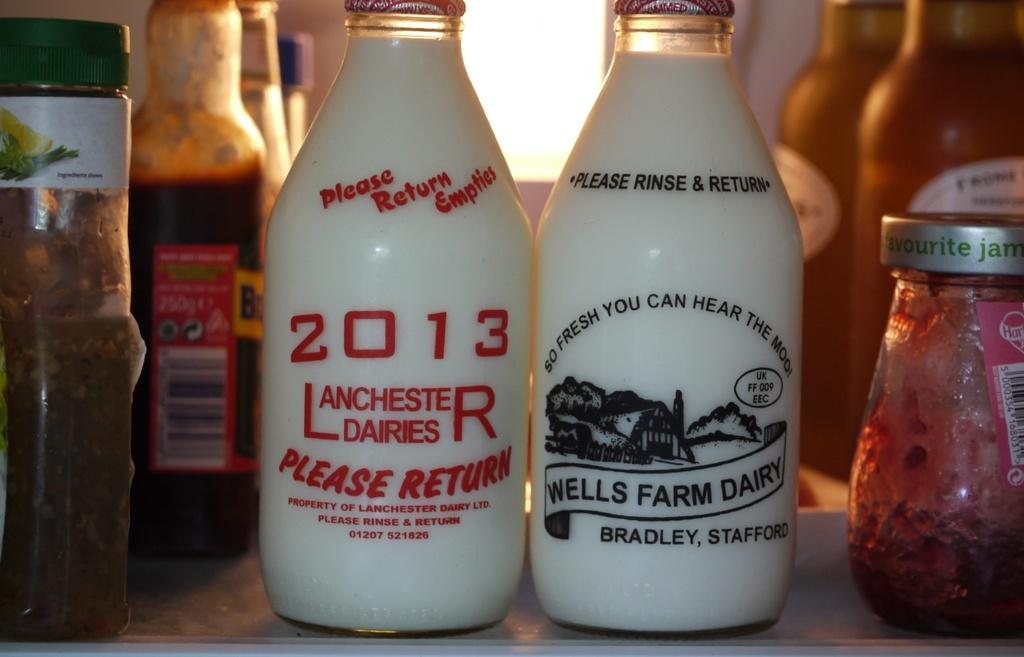<image>
Render a clear and concise summary of the photo. Two glass bottles of milk with one made by Wells Farm Dairy. 